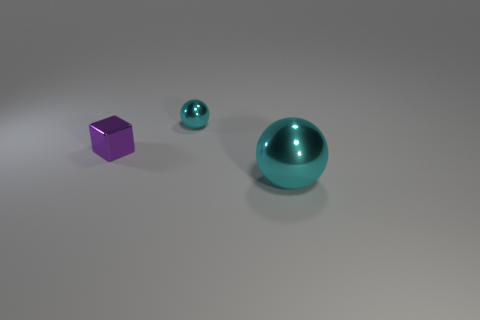Does the tiny shiny sphere have the same color as the metal ball that is in front of the tiny purple thing?
Your response must be concise. Yes. Is there anything else that has the same color as the small metallic sphere?
Provide a succinct answer. Yes. There is a shiny object that is the same color as the small shiny sphere; what is its size?
Make the answer very short. Large. What number of other objects are there of the same shape as the purple metallic thing?
Make the answer very short. 0. Is the color of the tiny thing that is right of the purple shiny object the same as the sphere in front of the tiny cyan shiny thing?
Make the answer very short. Yes. What number of tiny things are metal cubes or metallic spheres?
Make the answer very short. 2. What is the size of the other shiny thing that is the same shape as the small cyan thing?
Offer a terse response. Large. How many matte things are small purple cubes or large spheres?
Provide a short and direct response. 0. There is another metal object that is the same shape as the big cyan shiny thing; what color is it?
Keep it short and to the point. Cyan. How many small metallic things have the same color as the big object?
Your answer should be very brief. 1. 